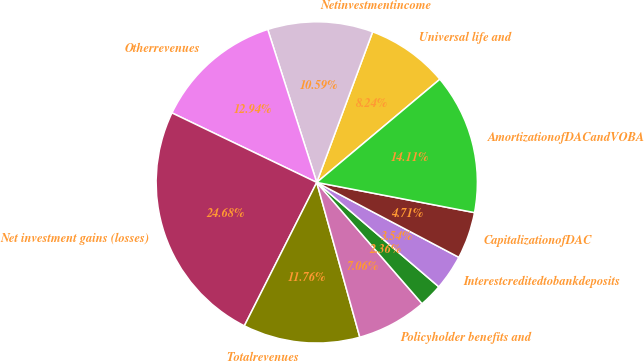<chart> <loc_0><loc_0><loc_500><loc_500><pie_chart><fcel>Universal life and<fcel>Netinvestmentincome<fcel>Otherrevenues<fcel>Net investment gains (losses)<fcel>Totalrevenues<fcel>Policyholder benefits and<fcel>Unnamed: 6<fcel>Interestcreditedtobankdeposits<fcel>CapitalizationofDAC<fcel>AmortizationofDACandVOBA<nl><fcel>8.24%<fcel>10.59%<fcel>12.94%<fcel>24.68%<fcel>11.76%<fcel>7.06%<fcel>2.36%<fcel>3.54%<fcel>4.71%<fcel>14.11%<nl></chart> 